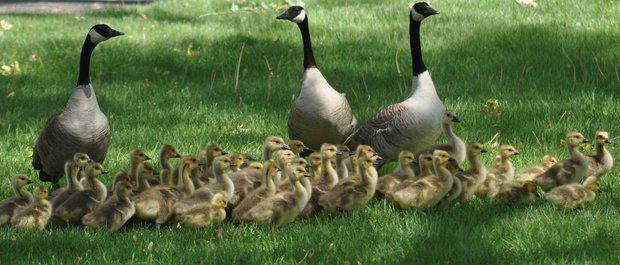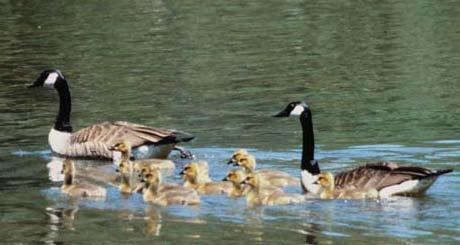The first image is the image on the left, the second image is the image on the right. Considering the images on both sides, is "two parents are swimming with their baby geese." valid? Answer yes or no. Yes. The first image is the image on the left, the second image is the image on the right. For the images displayed, is the sentence "The ducks are swimming in at least one of the images." factually correct? Answer yes or no. Yes. 